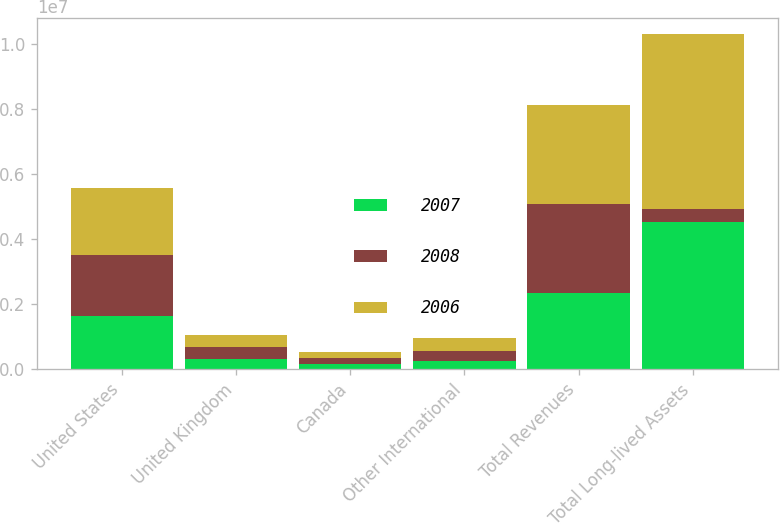Convert chart. <chart><loc_0><loc_0><loc_500><loc_500><stacked_bar_chart><ecel><fcel>United States<fcel>United Kingdom<fcel>Canada<fcel>Other International<fcel>Total Revenues<fcel>Total Long-lived Assets<nl><fcel>2007<fcel>1.64726e+06<fcel>312393<fcel>154801<fcel>235883<fcel>2.35034e+06<fcel>4.5298e+06<nl><fcel>2008<fcel>1.86281e+06<fcel>368008<fcel>179636<fcel>319582<fcel>2.73004e+06<fcel>400251<nl><fcel>2006<fcel>2.07488e+06<fcel>382971<fcel>197031<fcel>400251<fcel>3.05513e+06<fcel>5.38046e+06<nl></chart> 